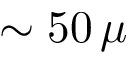Convert formula to latex. <formula><loc_0><loc_0><loc_500><loc_500>\sim 5 0 \, \mu</formula> 